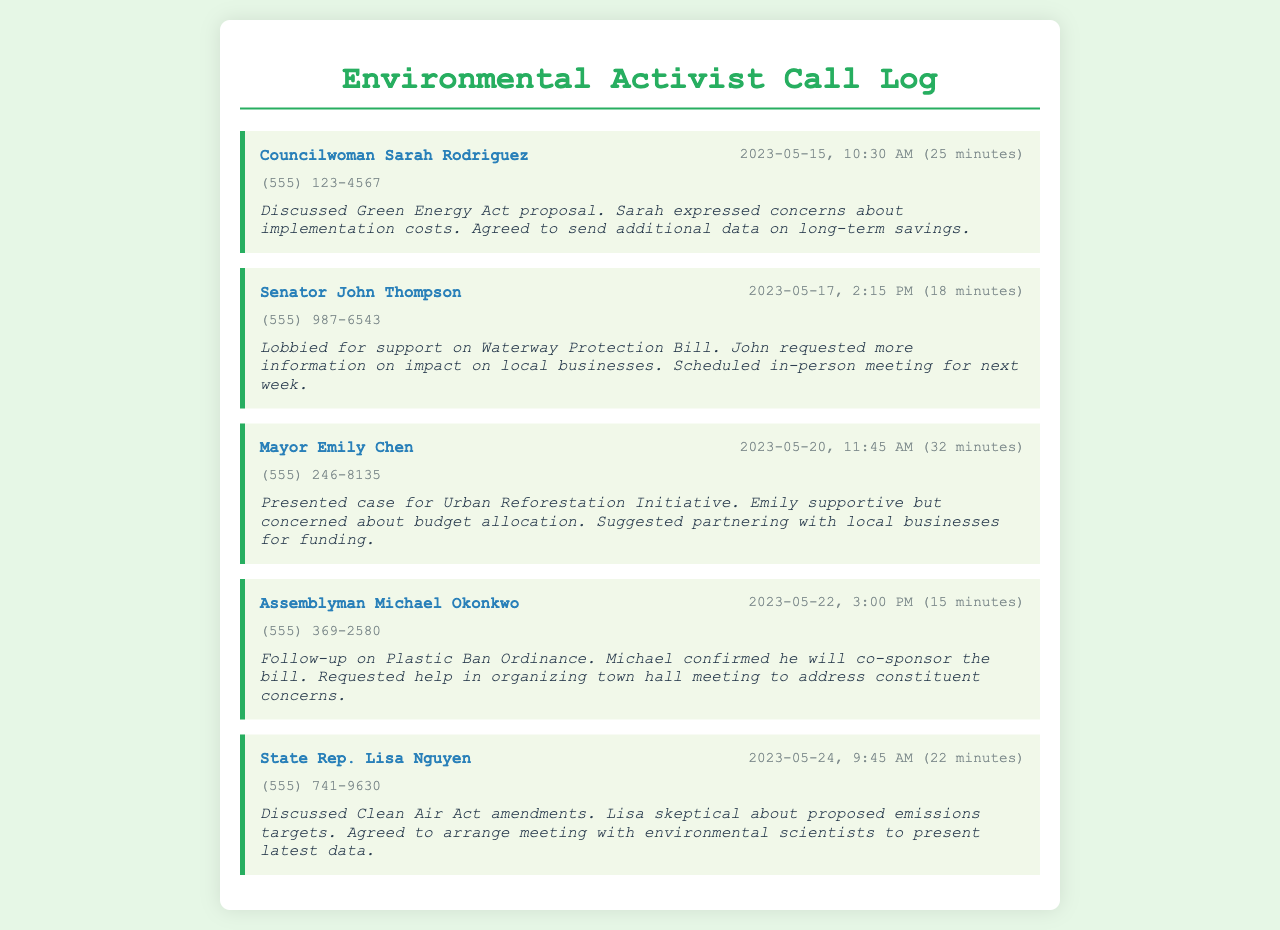What is the name of the first politician contacted? The first politician listed in the call log is Councilwoman Sarah Rodriguez.
Answer: Councilwoman Sarah Rodriguez On what date was the call with Senator John Thompson made? The call with Senator John Thompson occurred on May 17, 2023.
Answer: May 17, 2023 How long did the conversation with Mayor Emily Chen last? The conversation duration with Mayor Emily Chen was 32 minutes long.
Answer: 32 minutes What bill did Assemblyman Michael Okonkwo agree to co-sponsor? Assemblyman Michael Okonkwo confirmed he would co-sponsor the Plastic Ban Ordinance.
Answer: Plastic Ban Ordinance What concern did Mayor Emily Chen express during the call? Mayor Emily Chen was concerned about budget allocation for the Urban Reforestation Initiative.
Answer: budget allocation What did Lisa Nguyen agree to arrange after discussing the Clean Air Act amendments? Lisa Nguyen agreed to arrange a meeting with environmental scientists to present the latest data.
Answer: meeting with environmental scientists How many politicians were contacted according to the call log? There are five politicians listed in the call log.
Answer: five What was requested by Senator John Thompson regarding the Waterway Protection Bill? Senator John Thompson requested more information on the impact on local businesses.
Answer: more information on impact on local businesses What was the topic of the conversation with Councilwoman Sarah Rodriguez? The topic discussed was the Green Energy Act proposal.
Answer: Green Energy Act proposal 